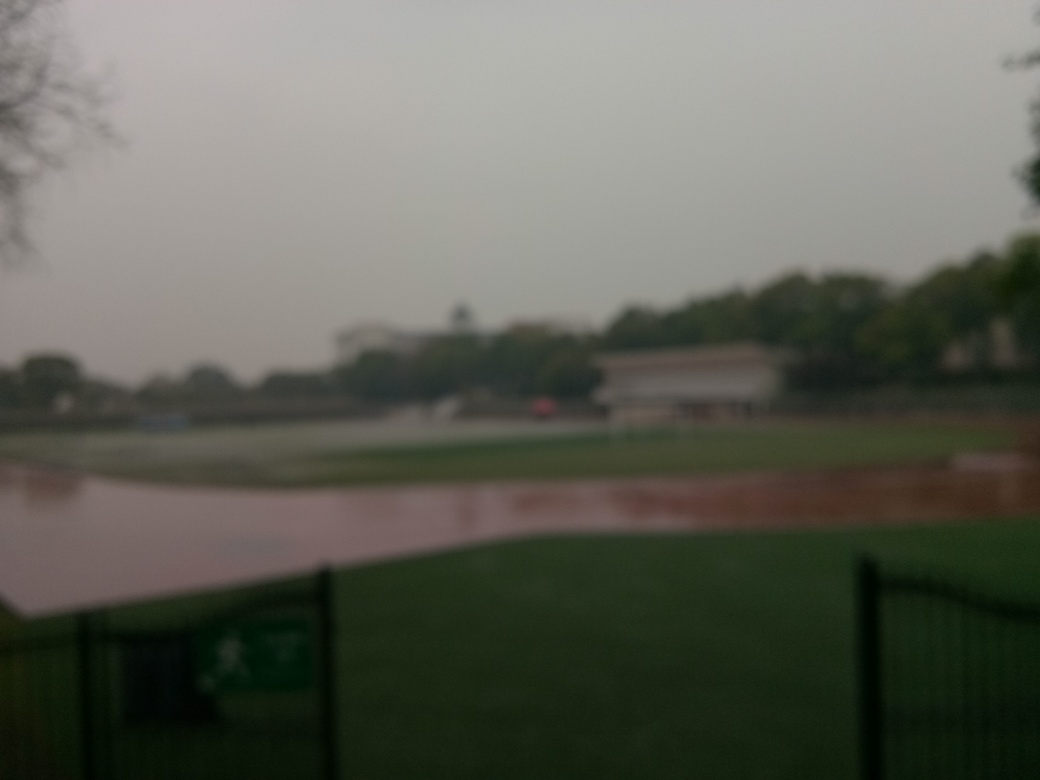Can you describe the setting or location depicted in this image? The image seems to capture a wide-open outdoor space, possibly a park or recreational area. There are hints of greenery that suggest grassy fields, and you can barely make out structures in the distance, which could be buildings or park facilities. The foreground features a fence, indicating a delineated area within this setting. Due to the quality issues, the finer details of the location are obscured. 